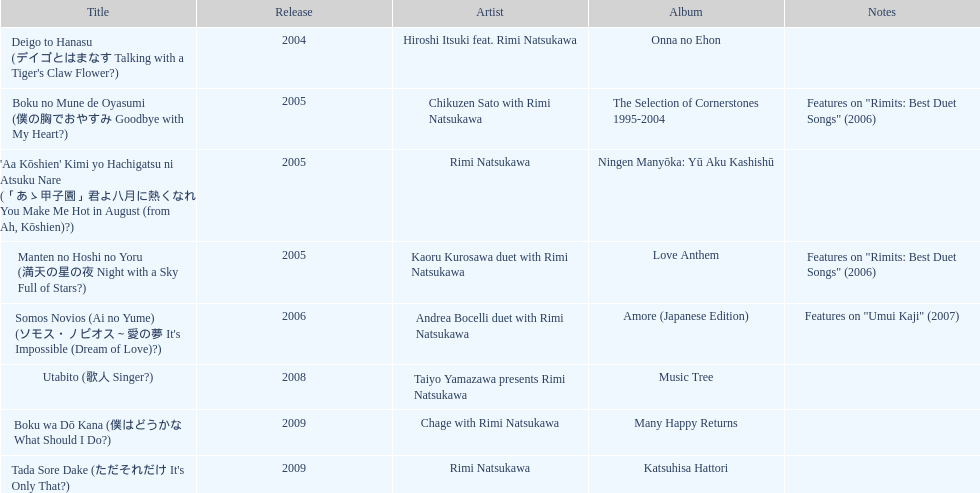What is the total count of albums rimi natsukawa has put out? 8. Could you help me parse every detail presented in this table? {'header': ['Title', 'Release', 'Artist', 'Album', 'Notes'], 'rows': [["Deigo to Hanasu (デイゴとはまなす Talking with a Tiger's Claw Flower?)", '2004', 'Hiroshi Itsuki feat. Rimi Natsukawa', 'Onna no Ehon', ''], ['Boku no Mune de Oyasumi (僕の胸でおやすみ Goodbye with My Heart?)', '2005', 'Chikuzen Sato with Rimi Natsukawa', 'The Selection of Cornerstones 1995-2004', 'Features on "Rimits: Best Duet Songs" (2006)'], ["'Aa Kōshien' Kimi yo Hachigatsu ni Atsuku Nare (「あゝ甲子園」君よ八月に熱くなれ You Make Me Hot in August (from Ah, Kōshien)?)", '2005', 'Rimi Natsukawa', 'Ningen Manyōka: Yū Aku Kashishū', ''], ['Manten no Hoshi no Yoru (満天の星の夜 Night with a Sky Full of Stars?)', '2005', 'Kaoru Kurosawa duet with Rimi Natsukawa', 'Love Anthem', 'Features on "Rimits: Best Duet Songs" (2006)'], ["Somos Novios (Ai no Yume) (ソモス・ノビオス～愛の夢 It's Impossible (Dream of Love)?)", '2006', 'Andrea Bocelli duet with Rimi Natsukawa', 'Amore (Japanese Edition)', 'Features on "Umui Kaji" (2007)'], ['Utabito (歌人 Singer?)', '2008', 'Taiyo Yamazawa presents Rimi Natsukawa', 'Music Tree', ''], ['Boku wa Dō Kana (僕はどうかな What Should I Do?)', '2009', 'Chage with Rimi Natsukawa', 'Many Happy Returns', ''], ["Tada Sore Dake (ただそれだけ It's Only That?)", '2009', 'Rimi Natsukawa', 'Katsuhisa Hattori', '']]} 